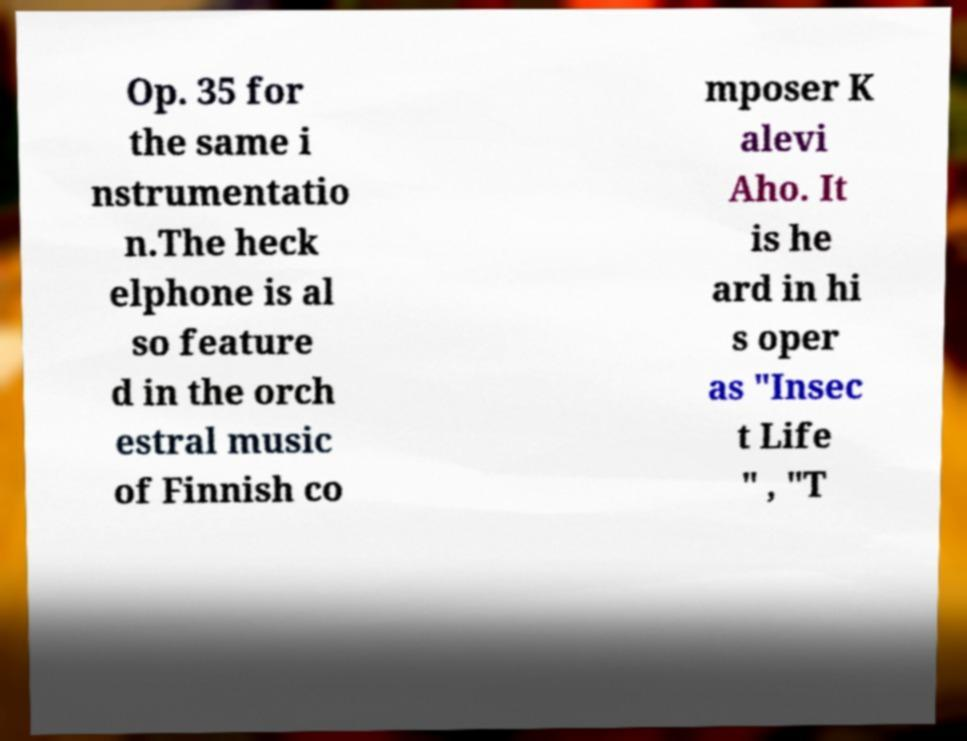Please identify and transcribe the text found in this image. Op. 35 for the same i nstrumentatio n.The heck elphone is al so feature d in the orch estral music of Finnish co mposer K alevi Aho. It is he ard in hi s oper as "Insec t Life " , "T 